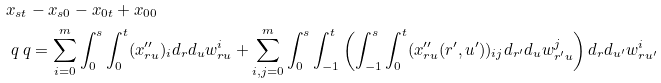<formula> <loc_0><loc_0><loc_500><loc_500>& x _ { s t } - x _ { s 0 } - x _ { 0 t } + x _ { 0 0 } \\ & \ q \ q = \sum _ { i = 0 } ^ { m } \int _ { 0 } ^ { s } \int _ { 0 } ^ { t } ( x _ { r u } ^ { \prime \prime } ) _ { i } d _ { r } d _ { u } w _ { r u } ^ { i } + \sum _ { i , j = 0 } ^ { m } \int _ { 0 } ^ { s } \int _ { - 1 } ^ { t } \left ( \int _ { - 1 } ^ { s } \int _ { 0 } ^ { t } ( x _ { r u } ^ { \prime \prime } ( r ^ { \prime } , u ^ { \prime } ) ) _ { i j } d _ { r ^ { \prime } } d _ { u } w _ { r ^ { \prime } u } ^ { j } \right ) d _ { r } d _ { u ^ { \prime } } w ^ { i } _ { r u ^ { \prime } } \\</formula> 